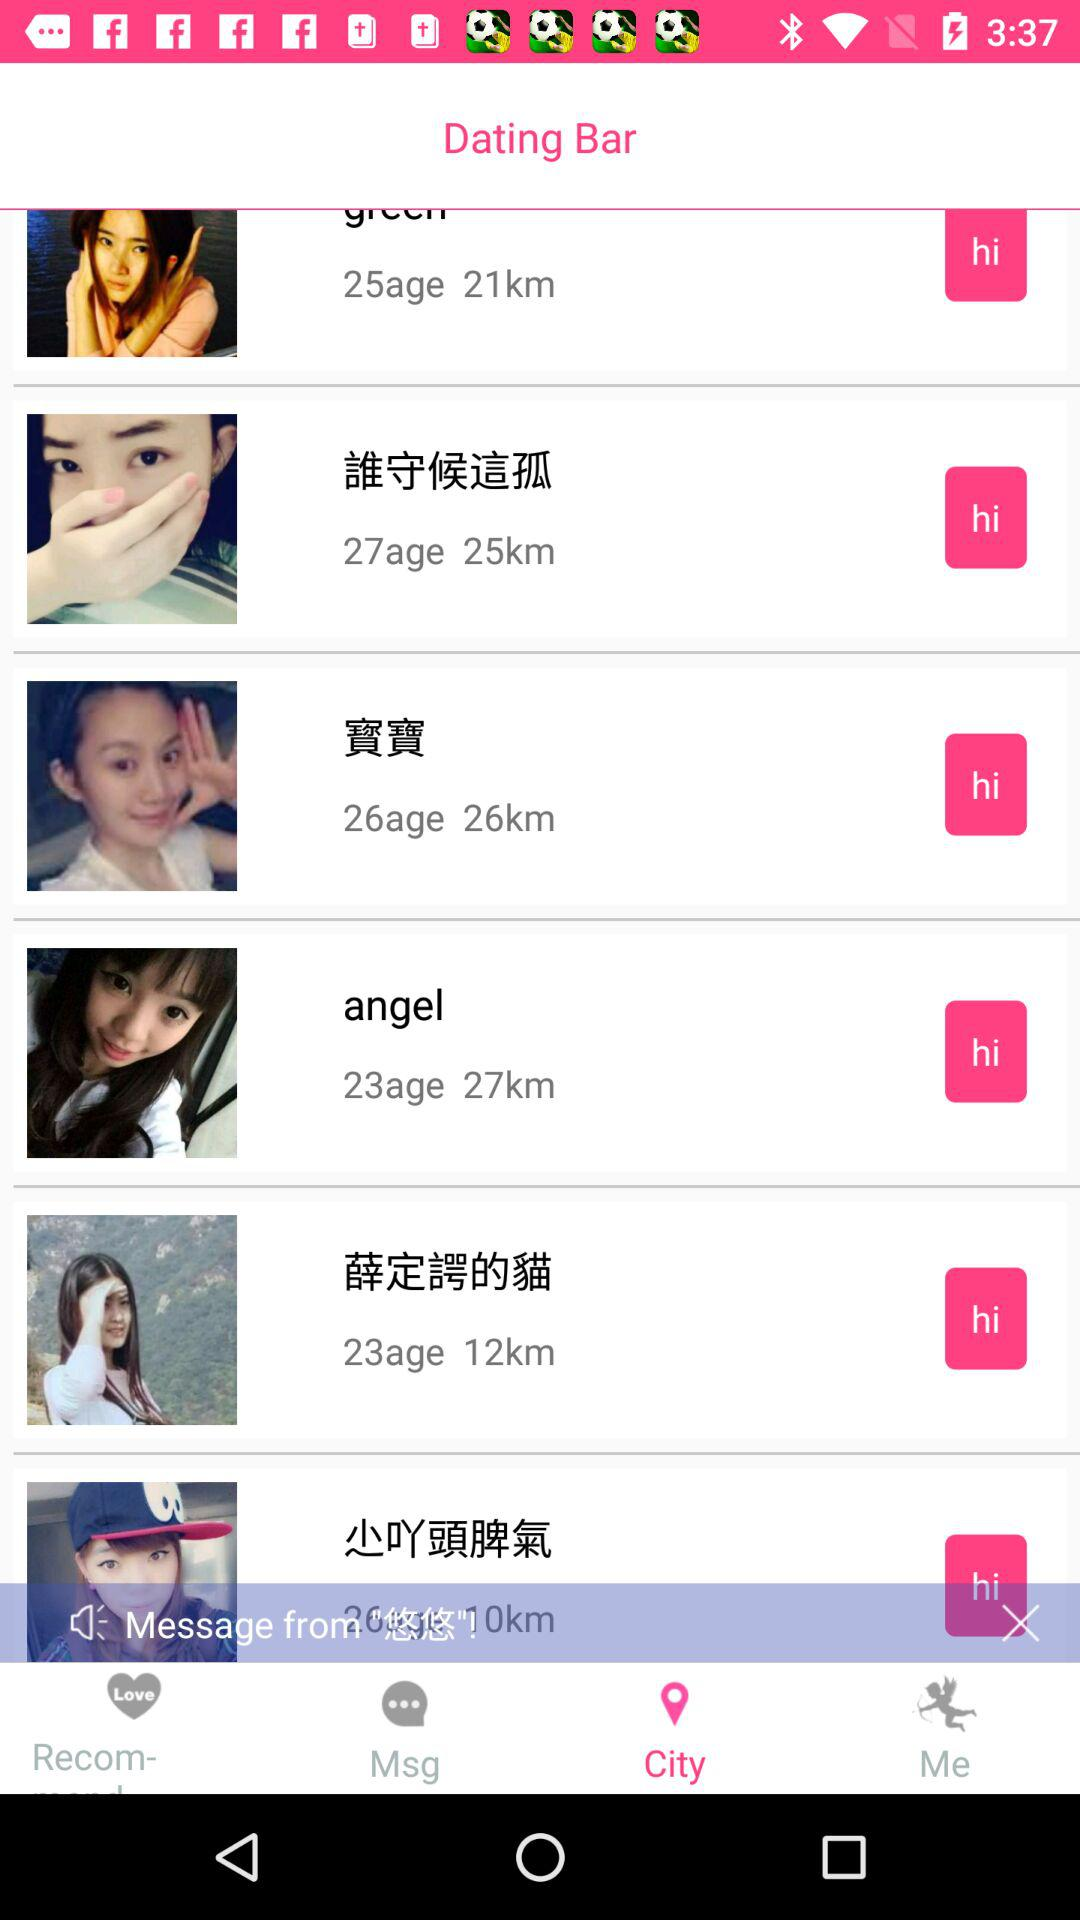What is the selected tab? The selected tab is "City". 